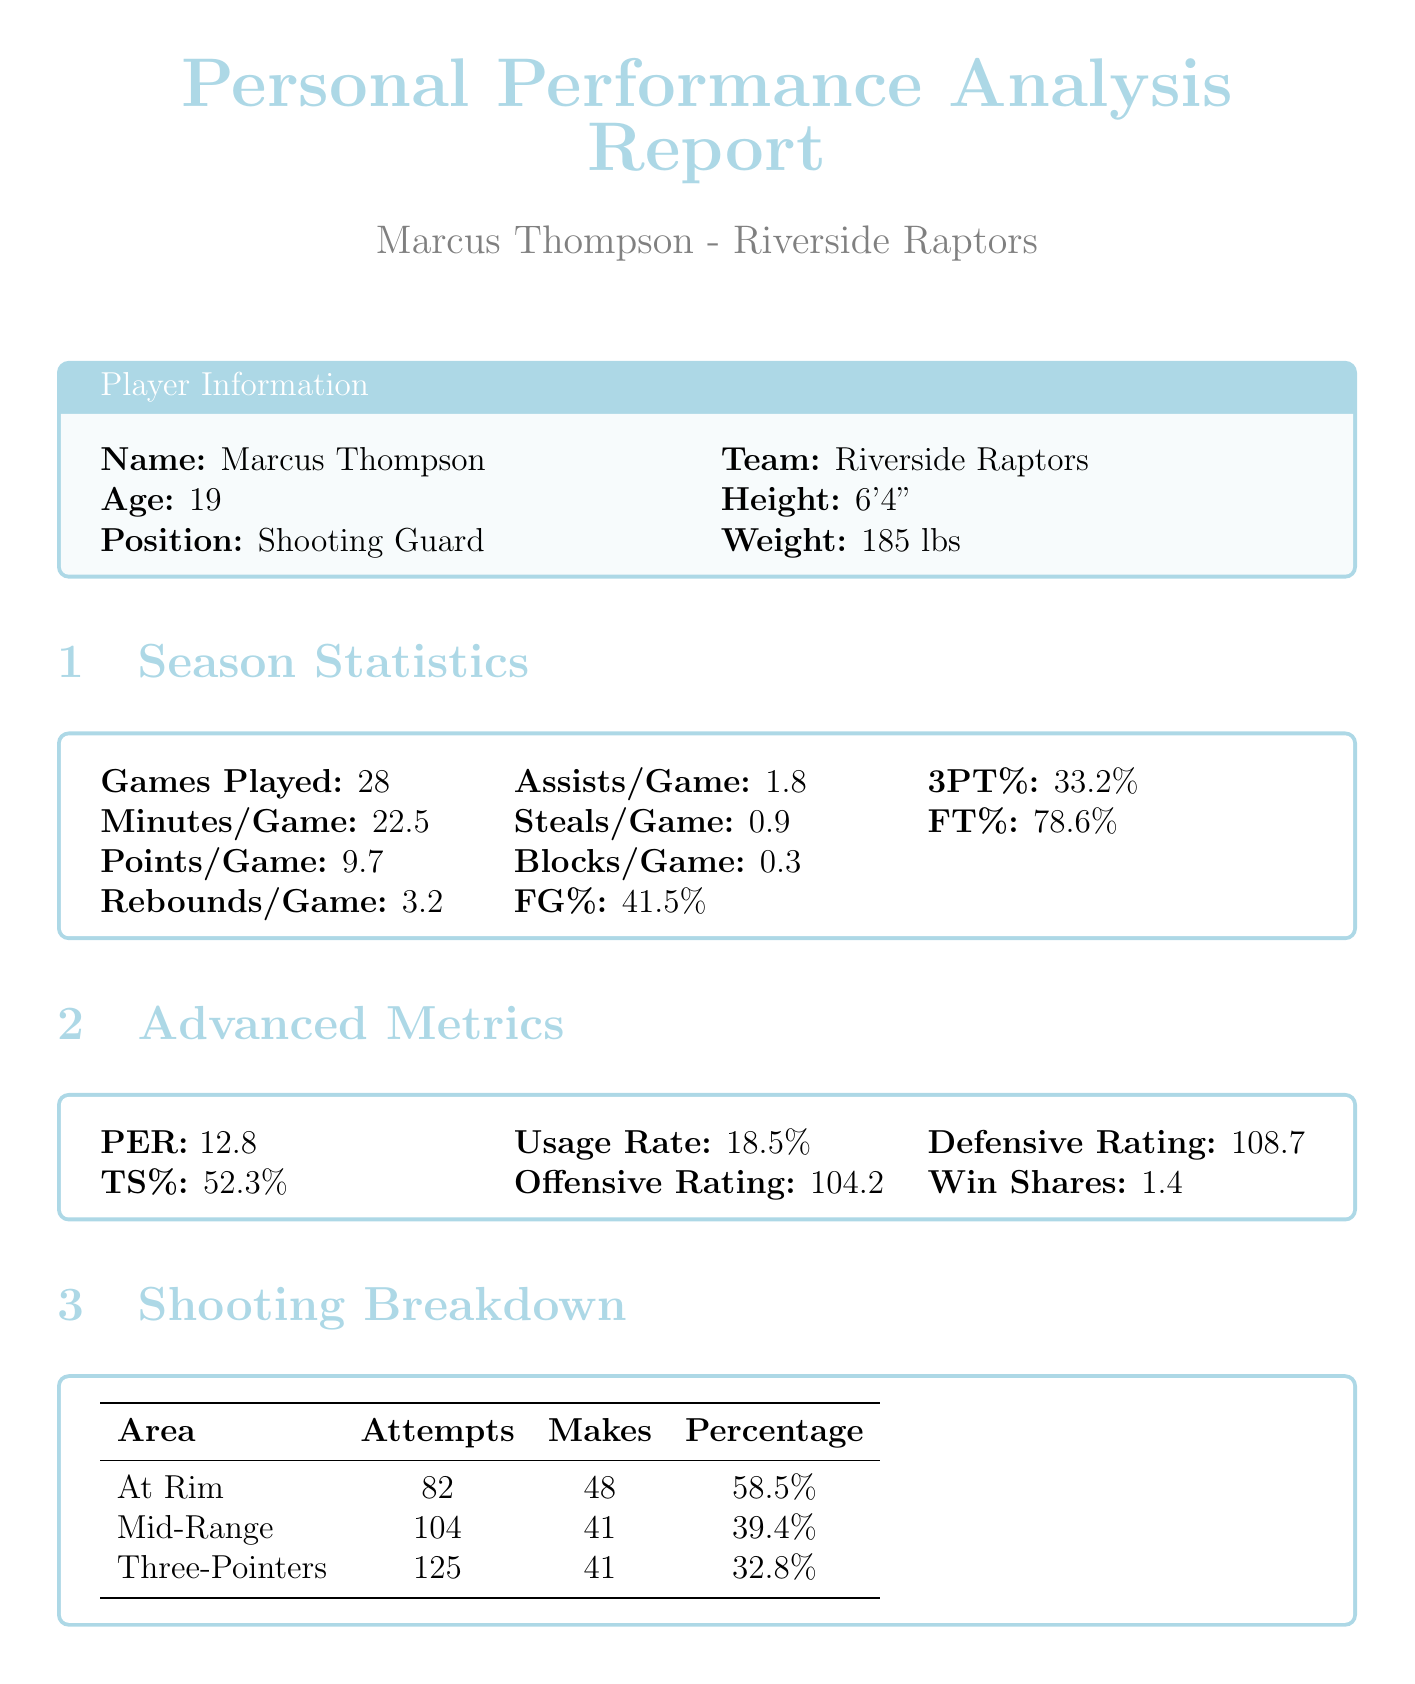What is Marcus Thompson's position? The document specifies that Marcus Thompson plays as a Shooting Guard.
Answer: Shooting Guard How many games did Marcus play this season? The report states that Marcus participated in 28 games this season.
Answer: 28 What is Marcus's field goal percentage? According to the statistics, the field goal percentage for Marcus is 41.5%.
Answer: 41.5% What is the key area of growth focused on three-point shooting? The growth area for three-point shooting includes improving consistency to become a reliable perimeter threat.
Answer: Improve consistency Who is the head coach for the Riverside Raptors? The document mentions that Coach Lisa Martinez is the head coach of the Riverside Raptors.
Answer: Coach Lisa Martinez What is the target points per game for Marcus in the short term? The performance goal for Marcus is to increase points per game to 12.5.
Answer: 12.5 List one of Marcus's strengths mentioned in the analysis. One of the strengths highlighted in the performance analysis is his good shooting form and mechanics.
Answer: Good shooting form and mechanics What duration is allocated for the focus area of mental toughness? The training focus for mental toughness is set for a duration of 4 weeks.
Answer: 4 weeks What is the total number of action items under the growth area of confidence and assertiveness? The report lists three action items under the growth area of confidence and assertiveness.
Answer: 3 